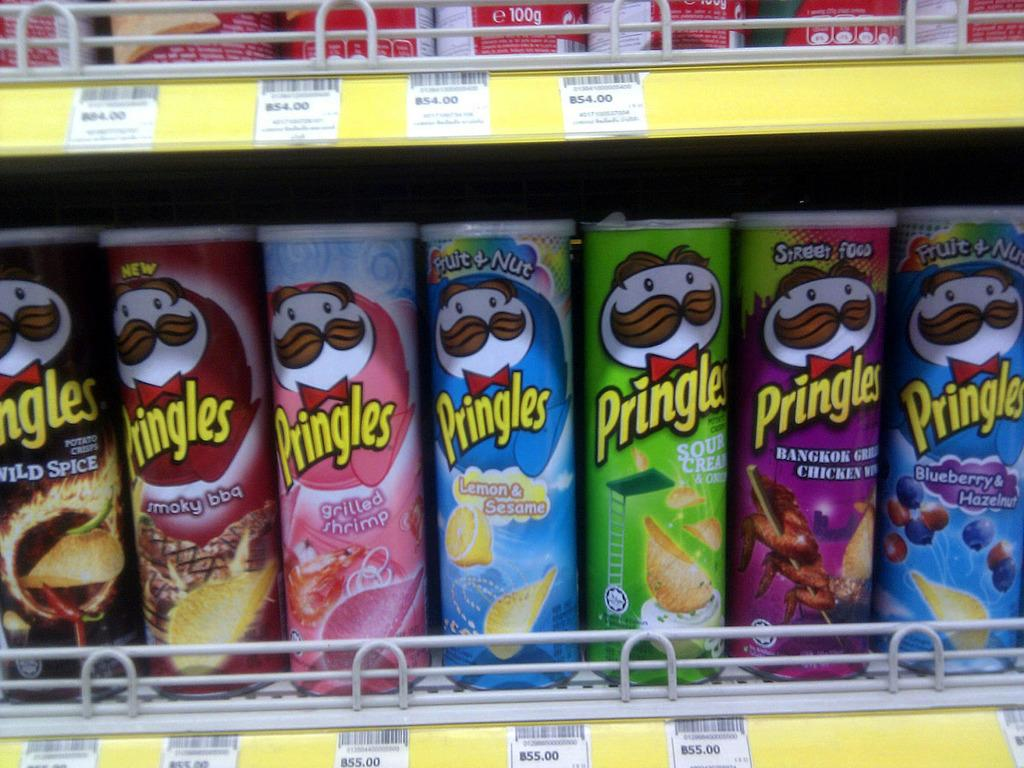<image>
Summarize the visual content of the image. A row of different flavors of Pringles chips on a store shelf. 